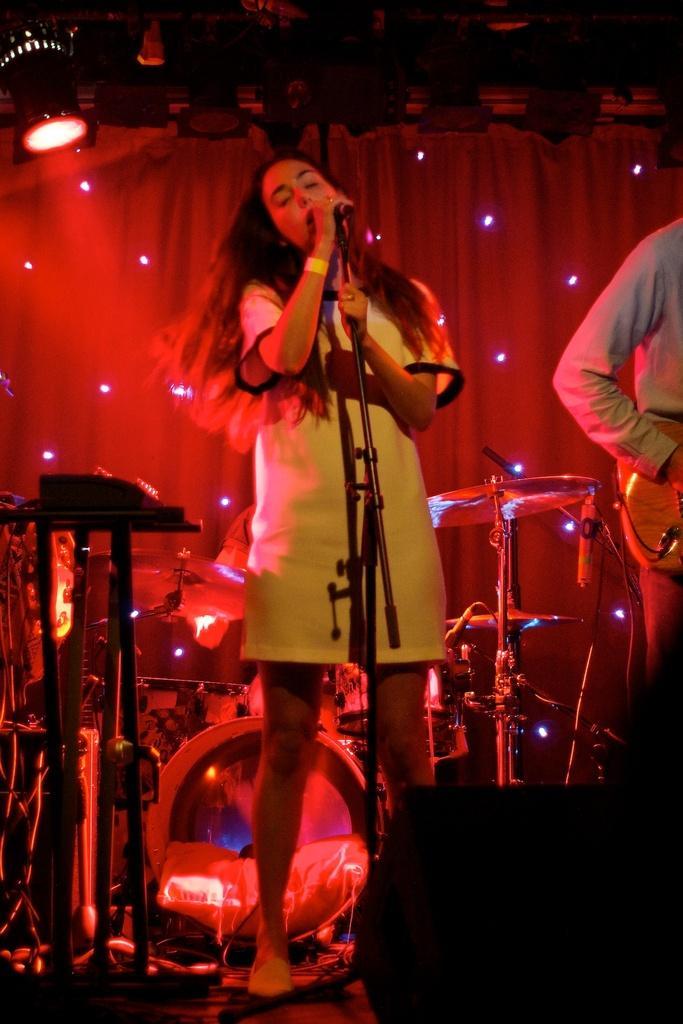Could you give a brief overview of what you see in this image? A lady is holding a mic and singing. In the background there is a drums, cymbal, mics. On the right side a person is standing. In the background there is a curtain. Lights are over there. 